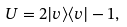<formula> <loc_0><loc_0><loc_500><loc_500>U = 2 | v \rangle \langle v | - { 1 } ,</formula> 